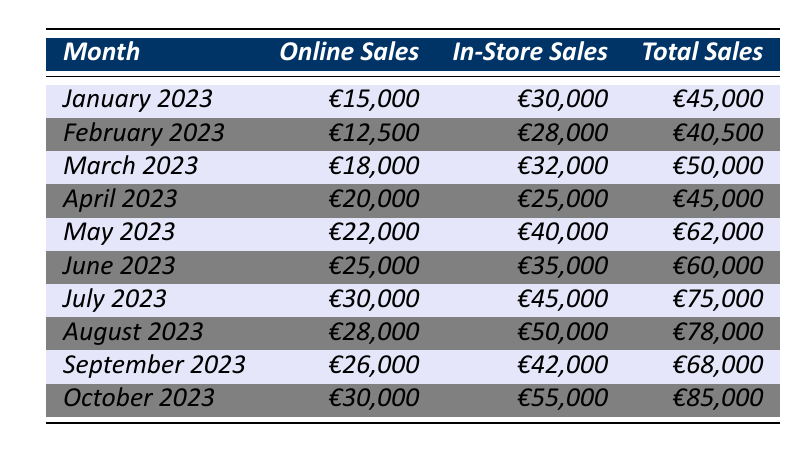What's the total sales for July 2023? In the table, under July 2023, the total sales value is listed as €75,000.
Answer: €75,000 Which month had the highest online sales? Looking at the online sales column, July 2023 shows the highest value of €30,000, compared to other months.
Answer: July 2023 How much more did in-store sales exceed online sales in May 2023? In May 2023, in-store sales were €40,000 while online sales were €22,000. The difference is €40,000 - €22,000 = €18,000.
Answer: €18,000 What is the total sales for the first half of 2023 (January to June)? The total sales for the first half are: January €45,000 + February €40,500 + March €50,000 + April €45,000 + May €62,000 + June €60,000 = €302,500.
Answer: €302,500 Did online sales exceed in-store sales in any month? By comparing the online and in-store sales column for each month, online sales only exceeded in-store sales in no month; in every month, in-store sales were higher.
Answer: No What was the average online sales from January to April 2023? Calculate the total online sales for January (€15,000), February (€12,500), March (€18,000), and April (€20,000) = €65,500. Then divide by 4 months. €65,500 / 4 = €16,375.
Answer: €16,375 In what month was the difference between in-store sales and total sales the smallest? To find the smallest difference, subtract each month's in-store sales from total sales. The smallest difference occurs in April 2023, where the difference is €45,000 - €25,000 = €20,000.
Answer: April 2023 What were the in-store sales in September 2023 compared to October 2023? September 2023 has in-store sales of €42,000 and October 2023 has €55,000. October's in-store sales are higher than September's by €55,000 - €42,000 = €13,000.
Answer: October 2023 is higher by €13,000 What is the total number of sales (online + in-store) for February and March 2023 combined? For February, total sales are €40,500 and for March, total sales are €50,000. Sum these values: €40,500 + €50,000 = €90,500.
Answer: €90,500 Was the total sales in August higher than June? August has total sales of €78,000, while June has €60,000. Since €78,000 is greater than €60,000, August total sales were higher.
Answer: Yes 